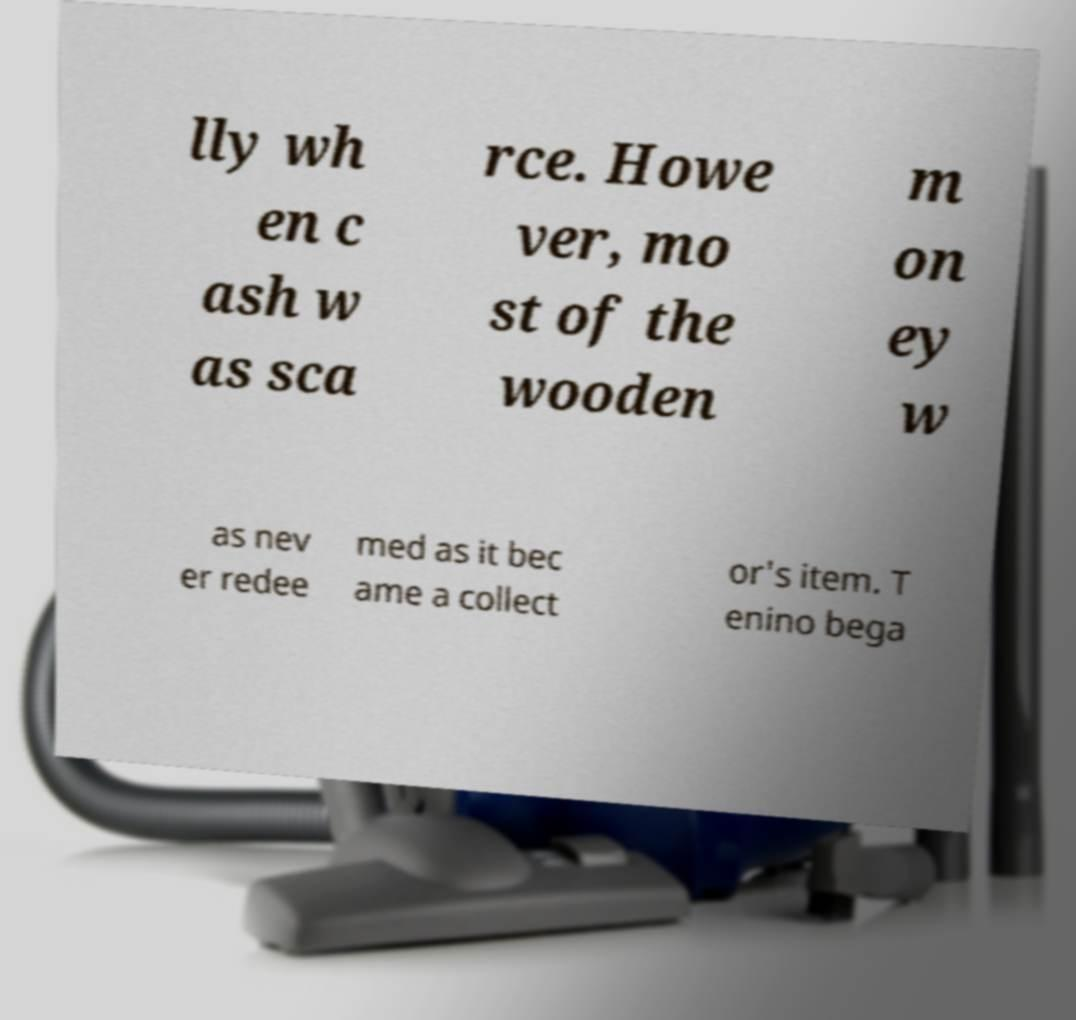Can you read and provide the text displayed in the image?This photo seems to have some interesting text. Can you extract and type it out for me? lly wh en c ash w as sca rce. Howe ver, mo st of the wooden m on ey w as nev er redee med as it bec ame a collect or's item. T enino bega 